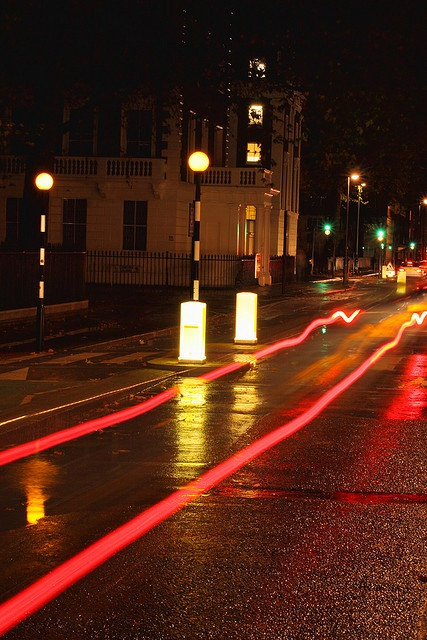Describe the objects in this image and their specific colors. I can see traffic light in black, maroon, olive, and ivory tones, traffic light in black, lightyellow, khaki, yellow, and brown tones, traffic light in black, ivory, lightgreen, olive, and green tones, traffic light in black, ivory, maroon, and darkgreen tones, and traffic light in black, darkgreen, and green tones in this image. 